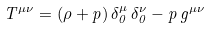Convert formula to latex. <formula><loc_0><loc_0><loc_500><loc_500>T ^ { \mu \nu } = ( \rho + p ) \, \delta ^ { \mu } _ { 0 } \, \delta ^ { \nu } _ { 0 } - p \, g ^ { \mu \nu }</formula> 